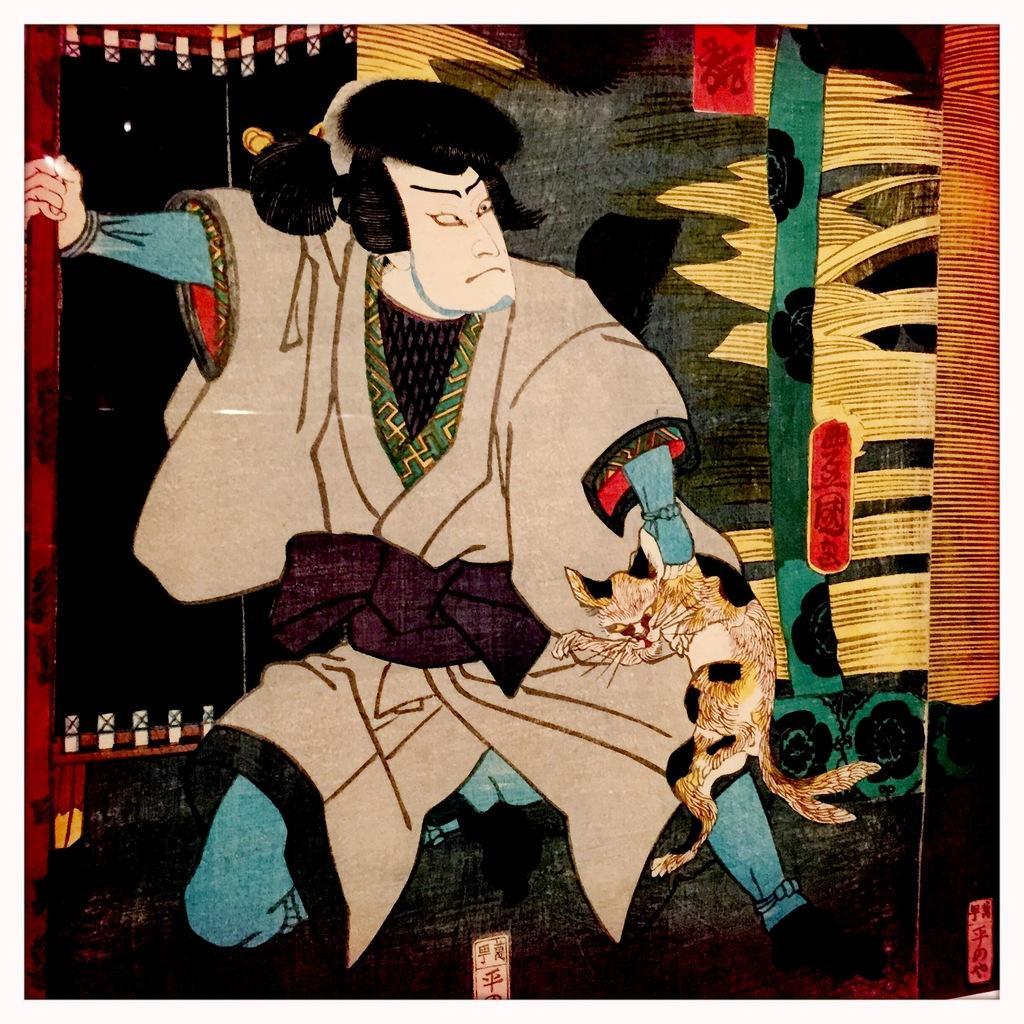Can you describe this image briefly? In this picture I can see a painting of a person holding a cat. 